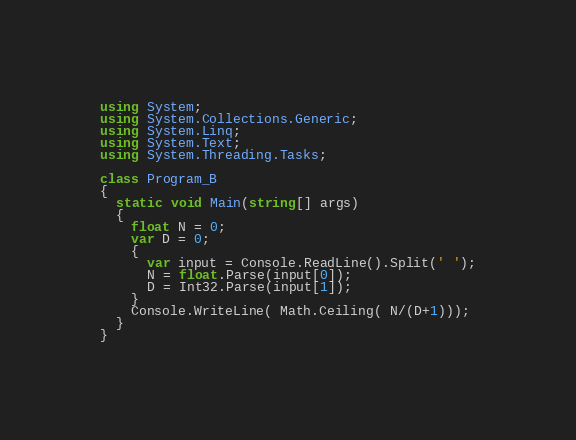Convert code to text. <code><loc_0><loc_0><loc_500><loc_500><_C#_>using System;
using System.Collections.Generic;
using System.Linq;
using System.Text;
using System.Threading.Tasks;

class Program_B
{
  static void Main(string[] args)
  {
    float N = 0;
    var D = 0;
    {
      var input = Console.ReadLine().Split(' ');
      N = float.Parse(input[0]);
      D = Int32.Parse(input[1]);
    }
    Console.WriteLine( Math.Ceiling( N/(D+1)));
  }
}

</code> 